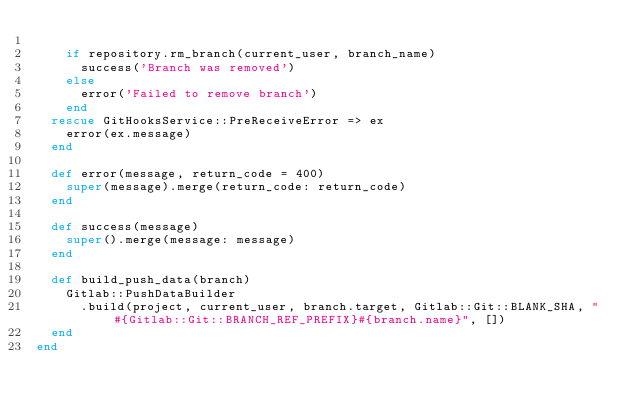Convert code to text. <code><loc_0><loc_0><loc_500><loc_500><_Ruby_>
    if repository.rm_branch(current_user, branch_name)
      success('Branch was removed')
    else
      error('Failed to remove branch')
    end
  rescue GitHooksService::PreReceiveError => ex
    error(ex.message)
  end

  def error(message, return_code = 400)
    super(message).merge(return_code: return_code)
  end

  def success(message)
    super().merge(message: message)
  end

  def build_push_data(branch)
    Gitlab::PushDataBuilder
      .build(project, current_user, branch.target, Gitlab::Git::BLANK_SHA, "#{Gitlab::Git::BRANCH_REF_PREFIX}#{branch.name}", [])
  end
end
</code> 